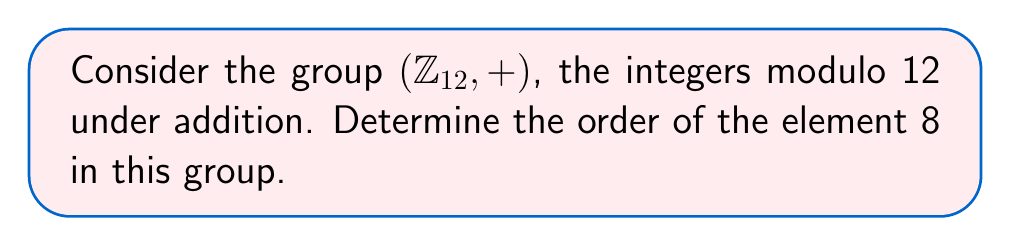Give your solution to this math problem. To determine the order of an element in a finite group, we need to find the smallest positive integer $n$ such that the element raised to the power $n$ (or added to itself $n$ times in an additive group) equals the identity element.

For the group $(\mathbb{Z}_{12}, +)$:

1. The identity element is 0.
2. We need to find the smallest positive integer $n$ such that $8n \equiv 0 \pmod{12}$.

Let's compute the multiples of 8 modulo 12:

1. $8 \cdot 1 \equiv 8 \pmod{12}$
2. $8 \cdot 2 \equiv 16 \equiv 4 \pmod{12}$
3. $8 \cdot 3 \equiv 24 \equiv 0 \pmod{12}$

We see that $8 \cdot 3 \equiv 0 \pmod{12}$, and this is the smallest positive integer that satisfies the condition.

Therefore, the order of the element 8 in $(\mathbb{Z}_{12}, +)$ is 3.

To verify, we can check that no smaller positive integer works:
- $8 \cdot 1 \not\equiv 0 \pmod{12}$
- $8 \cdot 2 \not\equiv 0 \pmod{12}$

This confirms that 3 is indeed the order of the element 8 in this group.
Answer: The order of the element 8 in $(\mathbb{Z}_{12}, +)$ is 3. 